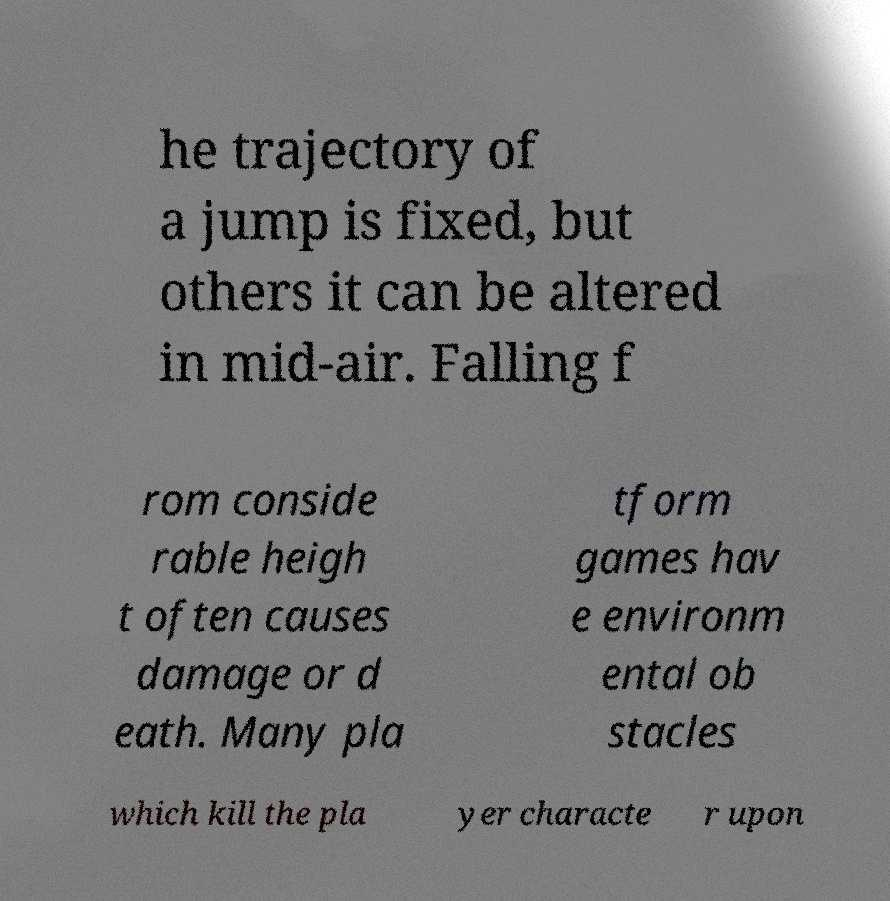Can you read and provide the text displayed in the image?This photo seems to have some interesting text. Can you extract and type it out for me? he trajectory of a jump is fixed, but others it can be altered in mid-air. Falling f rom conside rable heigh t often causes damage or d eath. Many pla tform games hav e environm ental ob stacles which kill the pla yer characte r upon 